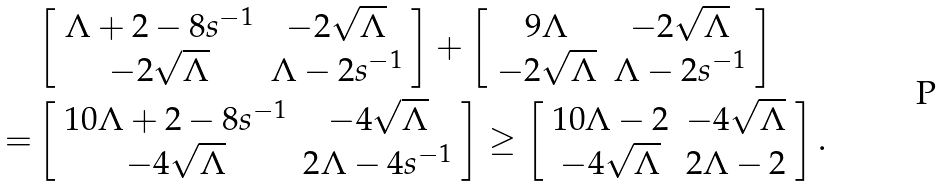<formula> <loc_0><loc_0><loc_500><loc_500>& \left [ \begin{array} { c c } \Lambda + 2 - 8 s ^ { - 1 } & - 2 \sqrt { \Lambda } \\ - 2 \sqrt { \Lambda } & \Lambda - 2 s ^ { - 1 } \end{array} \right ] + \left [ \begin{array} { c c } 9 \Lambda & - 2 \sqrt { \Lambda } \\ - 2 \sqrt { \Lambda } & \Lambda - 2 s ^ { - 1 } \end{array} \right ] \\ = & \left [ \begin{array} { c c } 1 0 \Lambda + 2 - 8 s ^ { - 1 } & - 4 \sqrt { \Lambda } \\ - 4 \sqrt { \Lambda } & 2 \Lambda - 4 s ^ { - 1 } \end{array} \right ] \geq \left [ \begin{array} { c c } 1 0 \Lambda - 2 & - 4 \sqrt { \Lambda } \\ - 4 \sqrt { \Lambda } & 2 \Lambda - 2 \end{array} \right ] .</formula> 